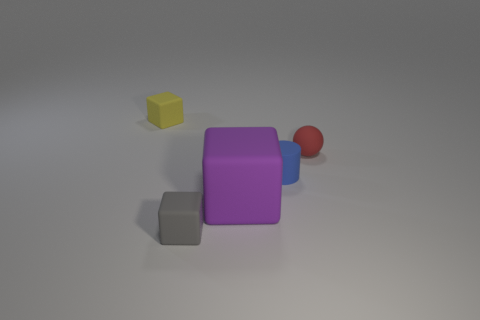Add 2 tiny red matte balls. How many objects exist? 7 Subtract all blocks. How many objects are left? 2 Subtract 0 cyan cylinders. How many objects are left? 5 Subtract all purple blocks. Subtract all matte balls. How many objects are left? 3 Add 5 big matte objects. How many big matte objects are left? 6 Add 3 purple objects. How many purple objects exist? 4 